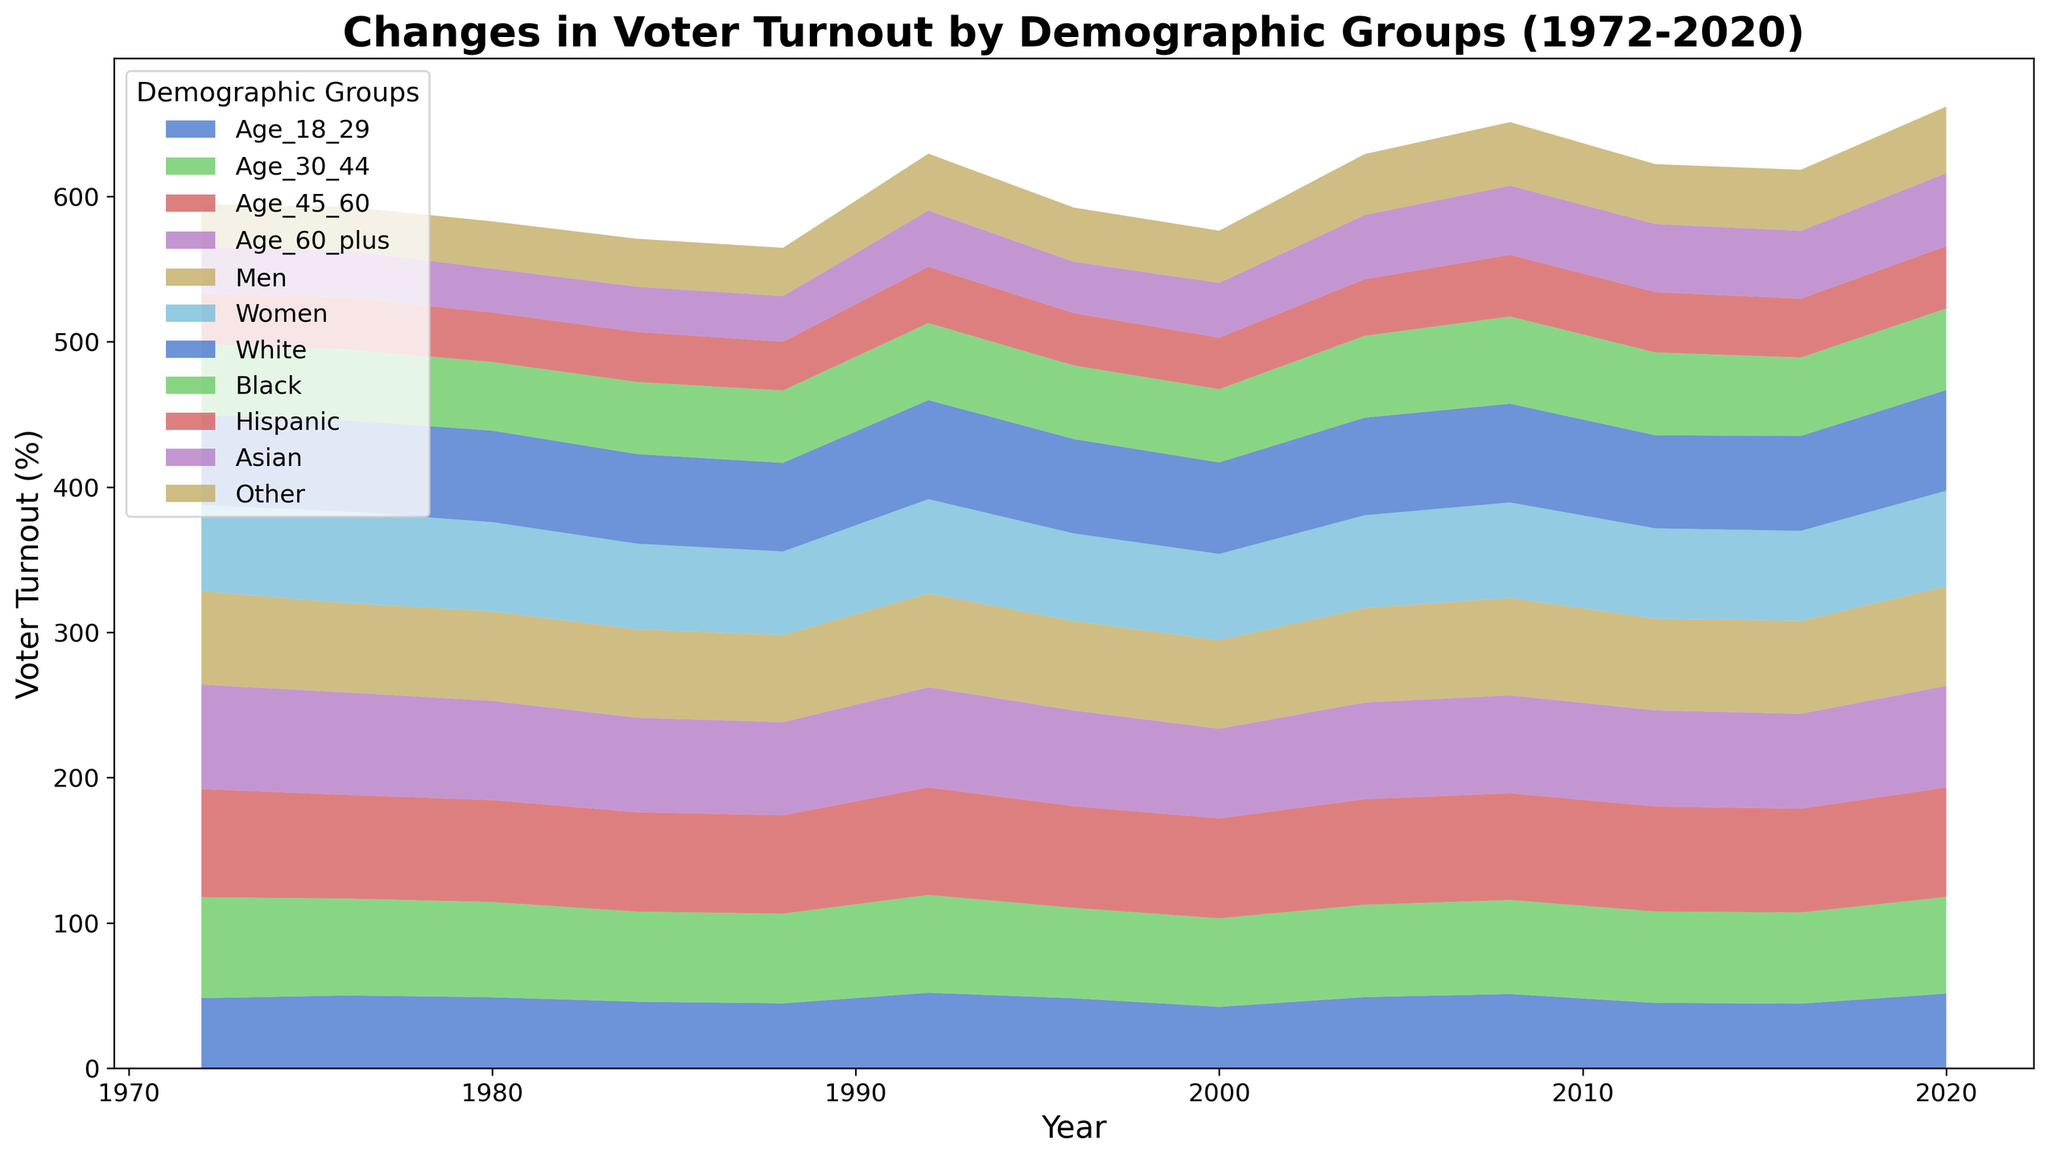What year did the voter turnout among the "Age_60_plus" demographic reach approximately 70% for the first time? We need to look for the first year where the "Age_60_plus" line reaches around the 70% mark. From the visual data, it is clear that this happened at the year 2020.
Answer: 2020 Which demographic group had the highest turnout in 2008? To determine this, we refer to the peak of the area chart in 2008. The "Age_45_60" segment appears to have the highest turnout.
Answer: Age_45_60 What is the overall trend in voter turnout for the "Hispanic" demographic group from 1972 to 2020? Observing the change in height of the "Hispanic" area over these years shows an upward trend, starting from around 34.6% in 1972 to approximately 43.0% in 2020.
Answer: Upward trend Compare the voter turnout percentage between "Men" and "Women" in 1992. Which group had a higher turnout and by how much? In 1992, "Men" had a turnout of 64.5% while "Women" had a turnout of 64.9%. The difference can be calculated by subtracting these values: 64.9% - 64.5% = 0.4%.
Answer: Women by 0.4% Which demographic group showed the lowest turnout during the 1988 election? Looking at the 1988 section of the area chart, the "Asian" group appears to have the lowest turnout.
Answer: Asian Identify the two age groups with the most notable decline in voter turnout between 1980 and 1984. Comparing the heights of "Age_18_29" and "Age_30_44" between 1980 and 1984 reveals a drop, with the decline being especially notable for "Age_18_29" and "Age_30_44".
Answer: Age_18_29 and Age_30_44 In which election year did the "Black" demographic group see a significant increase in voter turnout compared to the previous election? The largest noticeable increase in the "Black" area occurs between the 2000 and 2004 elections.
Answer: 2004 What is the average voter turnout for the "Women" demographic across the entire time period? Adding up the voter turnout values for "Women" from each year and then dividing by the number of years (12) results in an average turnout of 61.6%. [(59.1 + 63.0 + 61.4 + 58.9 + 57.5 + 64.9 + 60.3 + 59.4 + 63.8 + 65.7 + 62.1 + 62.0 + 65.8) / 13 = 61.6%]
Answer: 61.6% How did the voter turnout among "White" and "Other" demographics compare in 2020? We look at the respective heights for the "White" and "Other" segments in the year 2020. The "White" demographic had a turnout of 69.3%, while the "Other" had a turnout of 45.8%.
Answer: White by 23.5% What's the median turnout for the "Men" demographic over the years? To find the median, list the percent values for "Men" in ascending order and pick the middle value. Sorting: [60.0, 60.9, 61.5, 61.6, 63.0, 63.9, 64.3, 64.5, 65.0, 67.0, 68.4]. The median is the middle value, which for an odd count is found directly (61.6).
Answer: 61.6% 